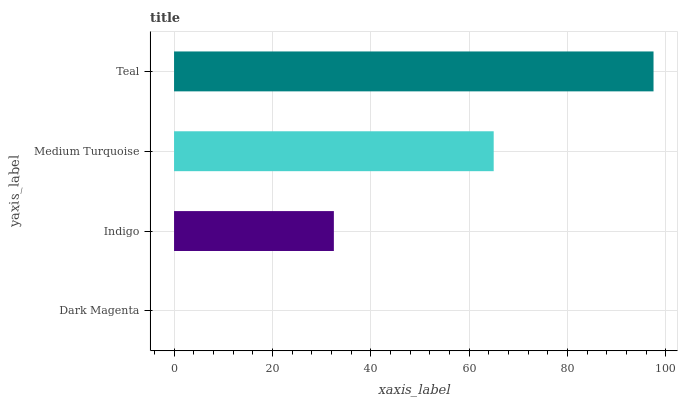Is Dark Magenta the minimum?
Answer yes or no. Yes. Is Teal the maximum?
Answer yes or no. Yes. Is Indigo the minimum?
Answer yes or no. No. Is Indigo the maximum?
Answer yes or no. No. Is Indigo greater than Dark Magenta?
Answer yes or no. Yes. Is Dark Magenta less than Indigo?
Answer yes or no. Yes. Is Dark Magenta greater than Indigo?
Answer yes or no. No. Is Indigo less than Dark Magenta?
Answer yes or no. No. Is Medium Turquoise the high median?
Answer yes or no. Yes. Is Indigo the low median?
Answer yes or no. Yes. Is Dark Magenta the high median?
Answer yes or no. No. Is Medium Turquoise the low median?
Answer yes or no. No. 